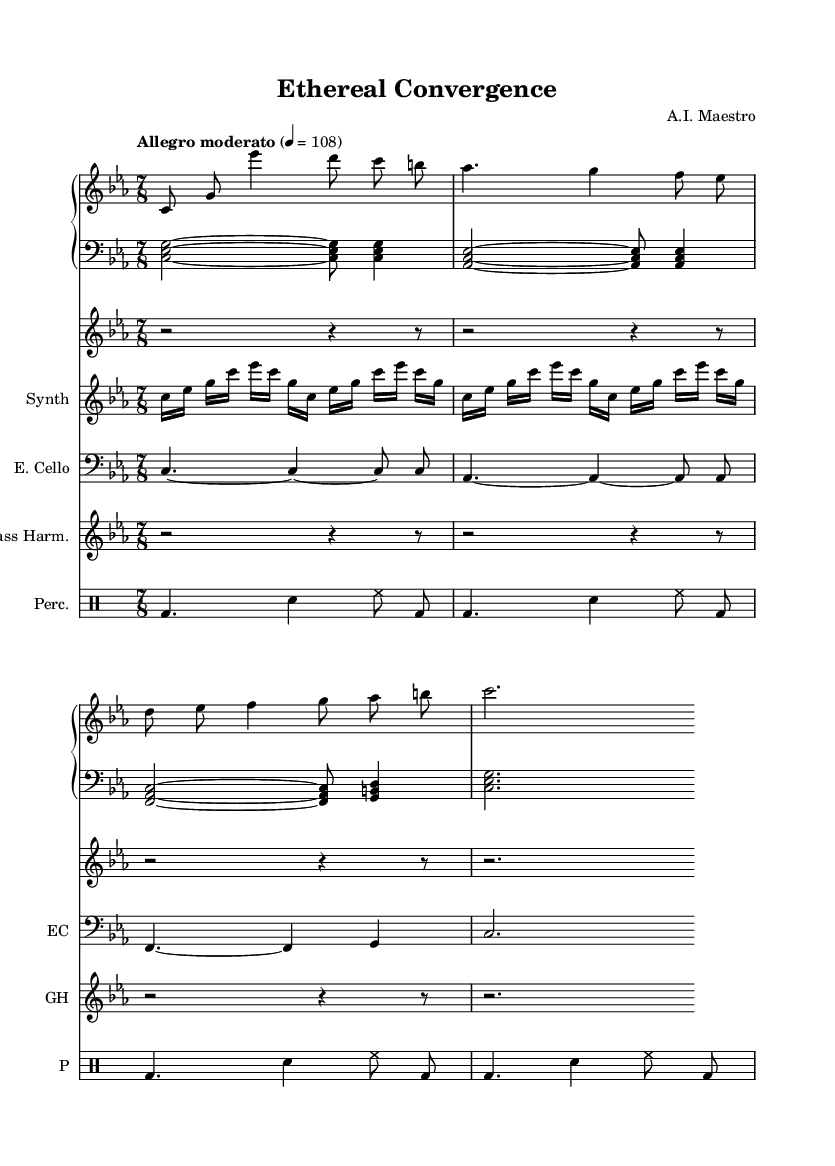What is the key signature of this music? The key signature is C minor, indicated by three flats (B, E, and A) on the staff.
Answer: C minor What is the time signature of this piece? The time signature is 7/8, which is displayed at the beginning of the sheet music. This indicates a compound meter with seven eighth-note beats per measure.
Answer: 7/8 What is the tempo marking for this composition? The tempo marking is "Allegro moderato," and it is set at a metronome marking of 108 beats per minute. This indicates a lively yet moderately paced performance.
Answer: Allegro moderato, 108 How many measures are present in the right hand? There are four measures in the right hand section, as indicated by the grouping of notes and vertical lines separating each measure.
Answer: 4 Which unconventional instrument is featured in this piece? The piece features a theremin, which is noted for its unique sound and electromagnetic control, contributing to the contemporary classical texture.
Answer: Theremin What technique is used by the electric cello player in the score? The electric cello is indicated to play sustained notes with ties, as reflected in the written notation showing long duration notes between notated values.
Answer: Sustained notes Which instrument plays the synthesizer arpeggios? The synthesizer plays the arpeggios as shown in the staff labeled "Synth" that includes rapid repetitions of the notes c, es, g.
Answer: Synthesizer 